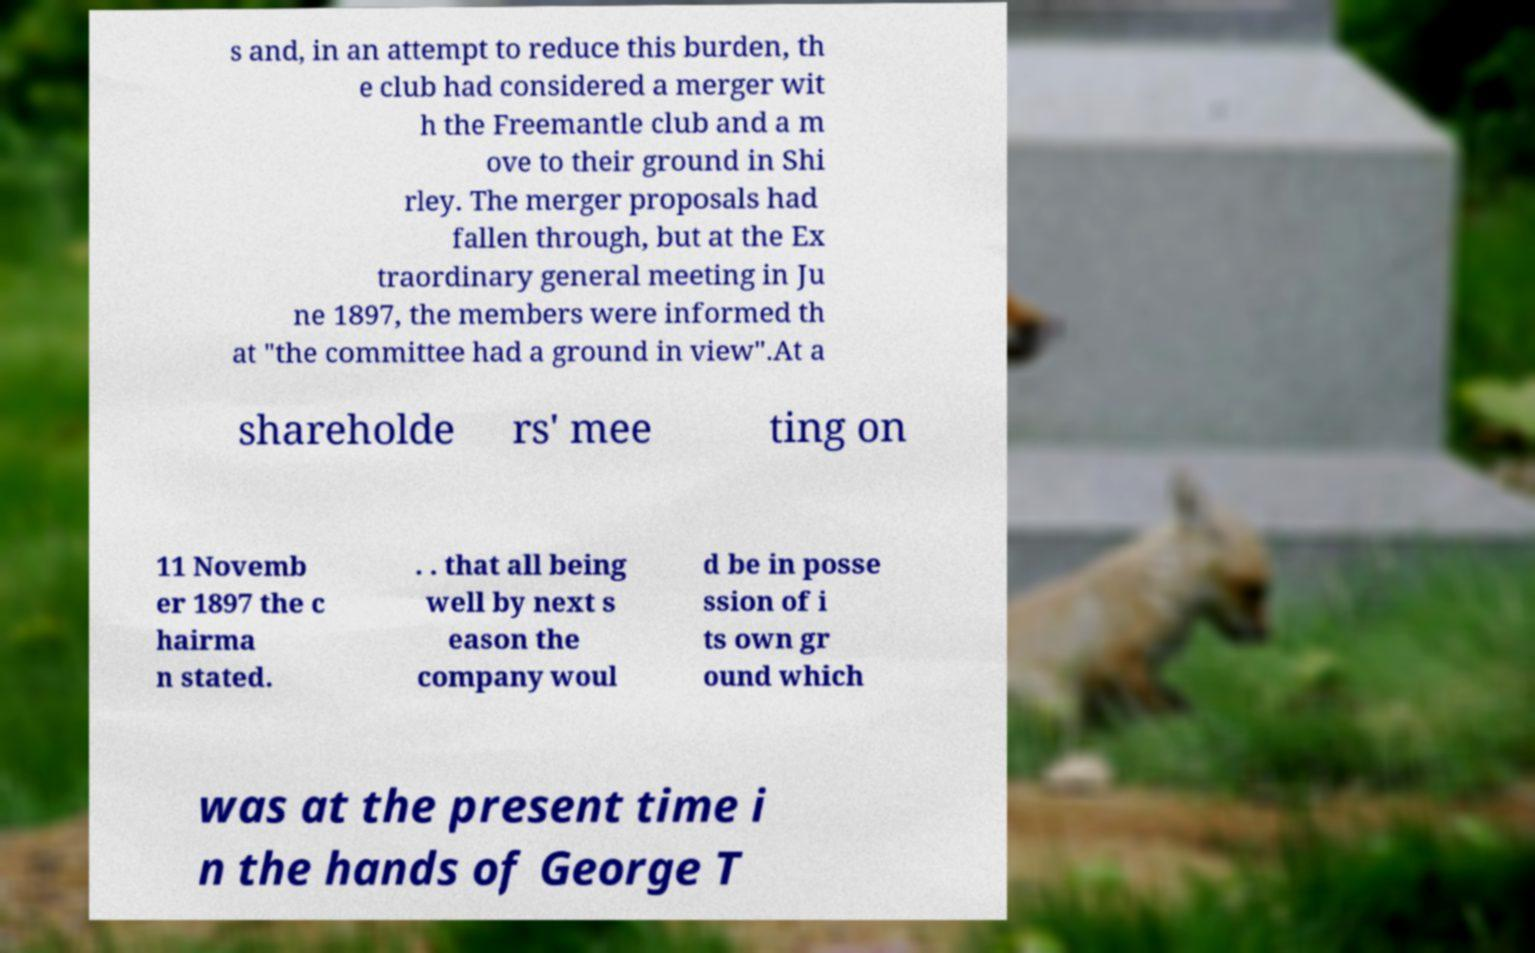Please read and relay the text visible in this image. What does it say? s and, in an attempt to reduce this burden, th e club had considered a merger wit h the Freemantle club and a m ove to their ground in Shi rley. The merger proposals had fallen through, but at the Ex traordinary general meeting in Ju ne 1897, the members were informed th at "the committee had a ground in view".At a shareholde rs' mee ting on 11 Novemb er 1897 the c hairma n stated. . . that all being well by next s eason the company woul d be in posse ssion of i ts own gr ound which was at the present time i n the hands of George T 